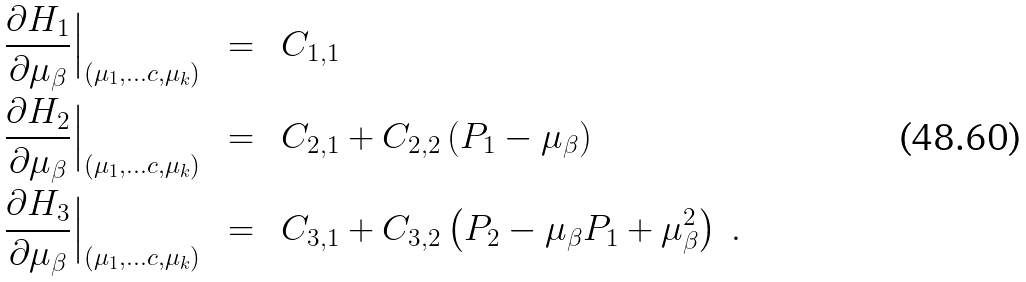Convert formula to latex. <formula><loc_0><loc_0><loc_500><loc_500>\frac { \partial H _ { 1 } } { \partial { \mu _ { \beta } } } \Big | _ { ( \mu _ { 1 } , \dots c , \mu _ { k } ) } \ \ & = \ \ C _ { 1 , 1 } \\ \frac { \partial H _ { 2 } } { \partial { \mu _ { \beta } } } \Big | _ { ( \mu _ { 1 } , \dots c , \mu _ { k } ) } \ \ & = \ \ C _ { 2 , 1 } + C _ { 2 , 2 } \left ( P _ { 1 } - \mu _ { \beta } \right ) \\ \frac { \partial H _ { 3 } } { \partial { \mu _ { \beta } } } \Big | _ { ( \mu _ { 1 } , \dots c , \mu _ { k } ) } \ \ & = \ \ C _ { 3 , 1 } + C _ { 3 , 2 } \left ( P _ { 2 } - \mu _ { \beta } P _ { 1 } + \mu _ { \beta } ^ { 2 } \right ) \ .</formula> 